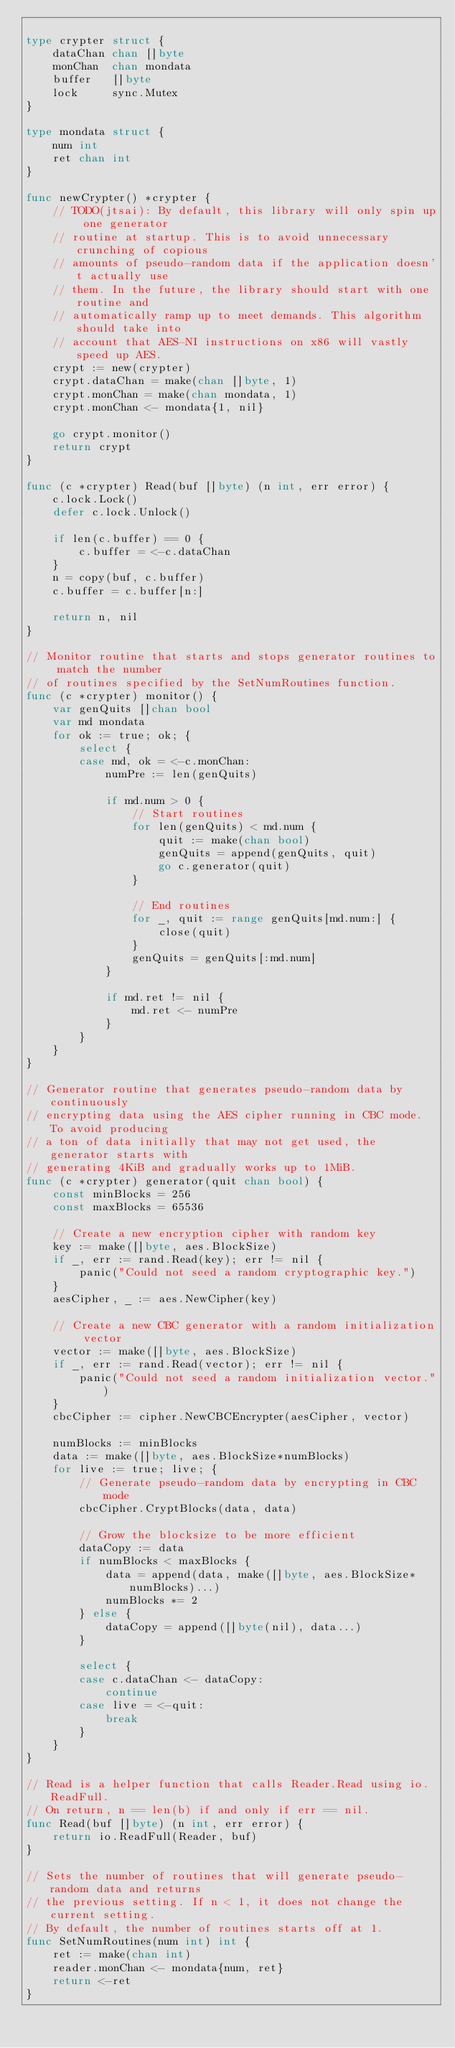<code> <loc_0><loc_0><loc_500><loc_500><_Go_>
type crypter struct {
	dataChan chan []byte
	monChan  chan mondata
	buffer   []byte
	lock     sync.Mutex
}

type mondata struct {
	num int
	ret chan int
}

func newCrypter() *crypter {
	// TODO(jtsai): By default, this library will only spin up one generator
	// routine at startup. This is to avoid unnecessary crunching of copious
	// amounts of pseudo-random data if the application doesn't actually use
	// them. In the future, the library should start with one routine and
	// automatically ramp up to meet demands. This algorithm should take into
	// account that AES-NI instructions on x86 will vastly speed up AES.
	crypt := new(crypter)
	crypt.dataChan = make(chan []byte, 1)
	crypt.monChan = make(chan mondata, 1)
	crypt.monChan <- mondata{1, nil}

	go crypt.monitor()
	return crypt
}

func (c *crypter) Read(buf []byte) (n int, err error) {
	c.lock.Lock()
	defer c.lock.Unlock()

	if len(c.buffer) == 0 {
		c.buffer = <-c.dataChan
	}
	n = copy(buf, c.buffer)
	c.buffer = c.buffer[n:]

	return n, nil
}

// Monitor routine that starts and stops generator routines to match the number
// of routines specified by the SetNumRoutines function.
func (c *crypter) monitor() {
	var genQuits []chan bool
	var md mondata
	for ok := true; ok; {
		select {
		case md, ok = <-c.monChan:
			numPre := len(genQuits)

			if md.num > 0 {
				// Start routines
				for len(genQuits) < md.num {
					quit := make(chan bool)
					genQuits = append(genQuits, quit)
					go c.generator(quit)
				}

				// End routines
				for _, quit := range genQuits[md.num:] {
					close(quit)
				}
				genQuits = genQuits[:md.num]
			}

			if md.ret != nil {
				md.ret <- numPre
			}
		}
	}
}

// Generator routine that generates pseudo-random data by continuously
// encrypting data using the AES cipher running in CBC mode. To avoid producing
// a ton of data initially that may not get used, the generator starts with
// generating 4KiB and gradually works up to 1MiB.
func (c *crypter) generator(quit chan bool) {
	const minBlocks = 256
	const maxBlocks = 65536

	// Create a new encryption cipher with random key
	key := make([]byte, aes.BlockSize)
	if _, err := rand.Read(key); err != nil {
		panic("Could not seed a random cryptographic key.")
	}
	aesCipher, _ := aes.NewCipher(key)

	// Create a new CBC generator with a random initialization vector
	vector := make([]byte, aes.BlockSize)
	if _, err := rand.Read(vector); err != nil {
		panic("Could not seed a random initialization vector.")
	}
	cbcCipher := cipher.NewCBCEncrypter(aesCipher, vector)

	numBlocks := minBlocks
	data := make([]byte, aes.BlockSize*numBlocks)
	for live := true; live; {
		// Generate pseudo-random data by encrypting in CBC mode
		cbcCipher.CryptBlocks(data, data)

		// Grow the blocksize to be more efficient
		dataCopy := data
		if numBlocks < maxBlocks {
			data = append(data, make([]byte, aes.BlockSize*numBlocks)...)
			numBlocks *= 2
		} else {
			dataCopy = append([]byte(nil), data...)
		}

		select {
		case c.dataChan <- dataCopy:
			continue
		case live = <-quit:
			break
		}
	}
}

// Read is a helper function that calls Reader.Read using io.ReadFull.
// On return, n == len(b) if and only if err == nil.
func Read(buf []byte) (n int, err error) {
	return io.ReadFull(Reader, buf)
}

// Sets the number of routines that will generate pseudo-random data and returns
// the previous setting. If n < 1, it does not change the current setting.
// By default, the number of routines starts off at 1.
func SetNumRoutines(num int) int {
	ret := make(chan int)
	reader.monChan <- mondata{num, ret}
	return <-ret
}
</code> 